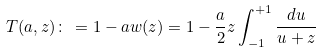<formula> <loc_0><loc_0><loc_500><loc_500>T ( a , z ) \colon \, = 1 - a w ( z ) = 1 - \frac { a } { 2 } z \int _ { - 1 } ^ { + 1 } \frac { d u } { u + z }</formula> 